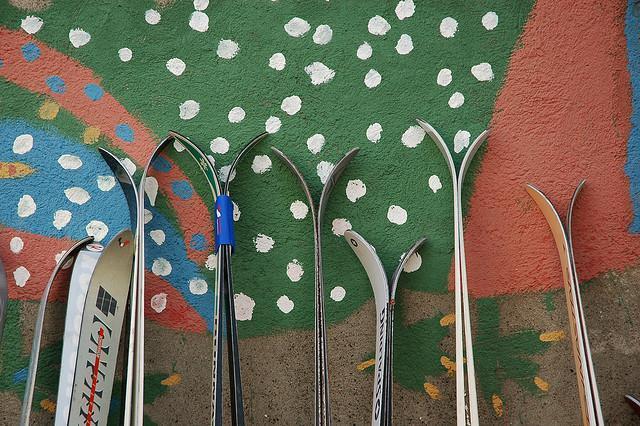How many ski are in the picture?
Give a very brief answer. 7. 